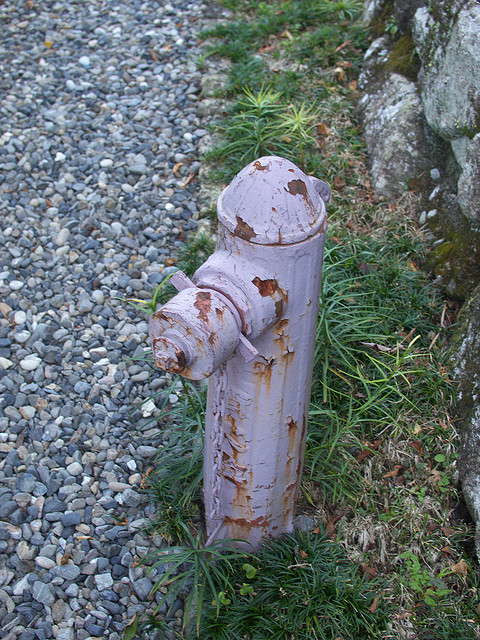Imagine if this fireplug could interact with time travelers from the past and the future. What would their conversations be like? A time traveler from the past might marvel at the fireplug's design and question its purpose, intrigued by this peculiar object standing guard in the landscape. The fireplug might explain its role in ensuring safety by providing water in emergencies, a concept that might be novel to someone from a time before modern firefighting infrastructure. A traveler from the future might approach the hydrant with a more nostalgic perspective, perhaps noting how primitive it looks compared to advanced fire-suppression systems of their time. They could discuss the evolution of firefighting technology and how something as simple yet crucial as a fireplug played a role in saving lives and properties through the ages. These conversations would blend history, technology, and the essential human drive to protect one another, bridging centuries of innovation and adaptation. 